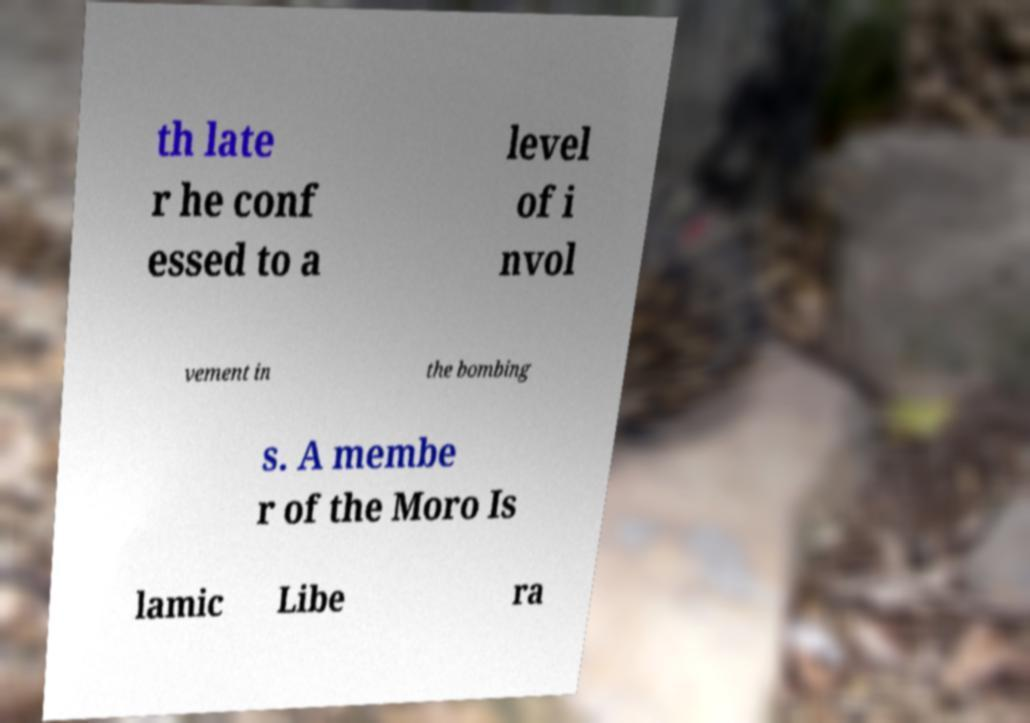I need the written content from this picture converted into text. Can you do that? th late r he conf essed to a level of i nvol vement in the bombing s. A membe r of the Moro Is lamic Libe ra 